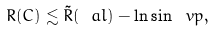<formula> <loc_0><loc_0><loc_500><loc_500>R ( C ) \lesssim \tilde { R } ( \ a l ) - \ln \sin \ v p ,</formula> 